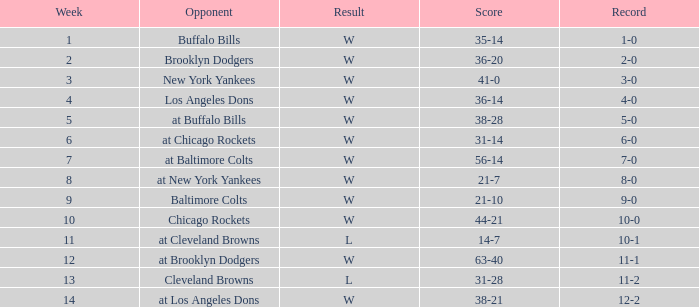Who was the opponent in week 13? Cleveland Browns. 